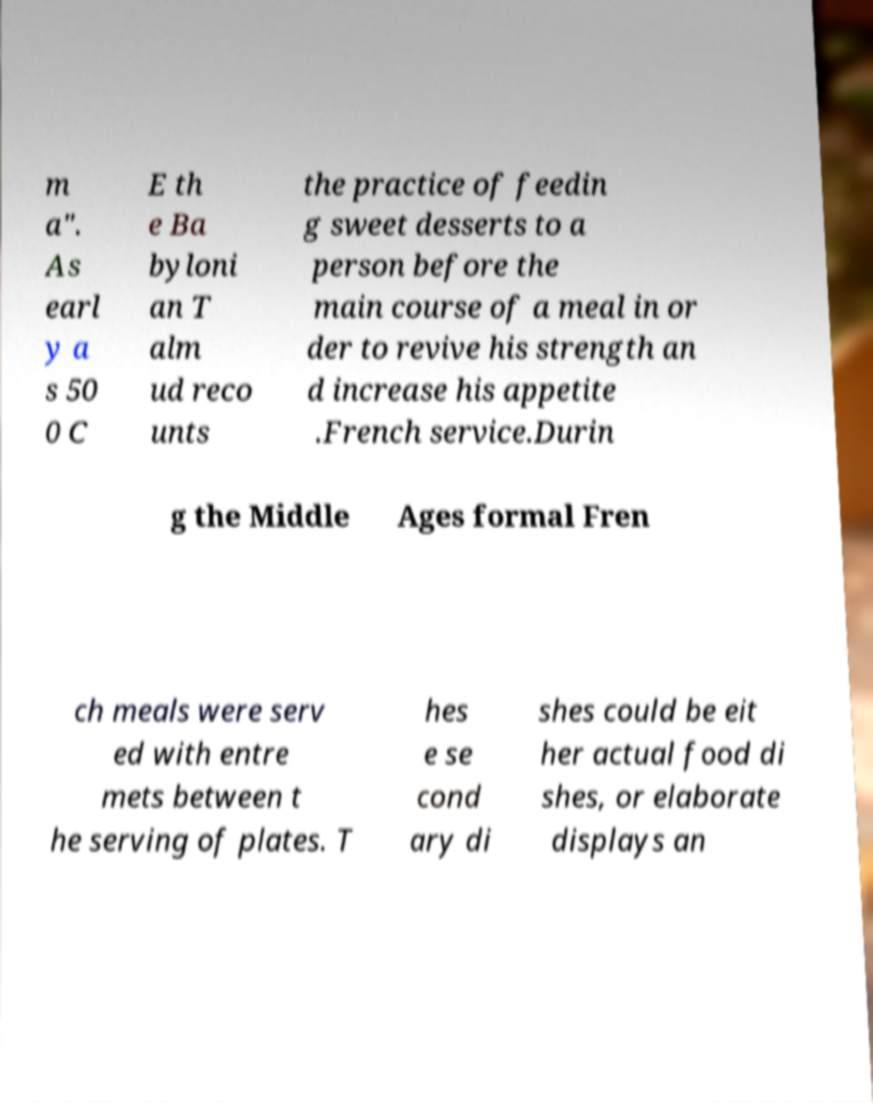I need the written content from this picture converted into text. Can you do that? m a". As earl y a s 50 0 C E th e Ba byloni an T alm ud reco unts the practice of feedin g sweet desserts to a person before the main course of a meal in or der to revive his strength an d increase his appetite .French service.Durin g the Middle Ages formal Fren ch meals were serv ed with entre mets between t he serving of plates. T hes e se cond ary di shes could be eit her actual food di shes, or elaborate displays an 